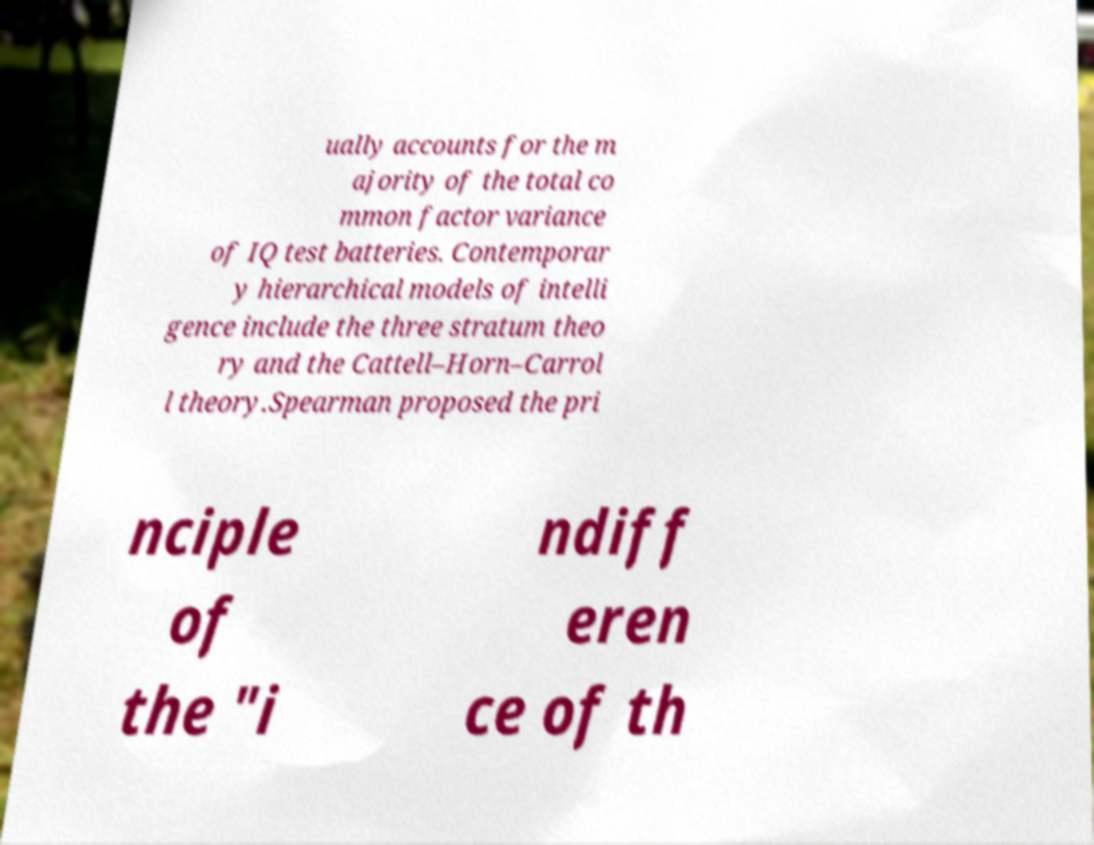There's text embedded in this image that I need extracted. Can you transcribe it verbatim? ually accounts for the m ajority of the total co mmon factor variance of IQ test batteries. Contemporar y hierarchical models of intelli gence include the three stratum theo ry and the Cattell–Horn–Carrol l theory.Spearman proposed the pri nciple of the "i ndiff eren ce of th 